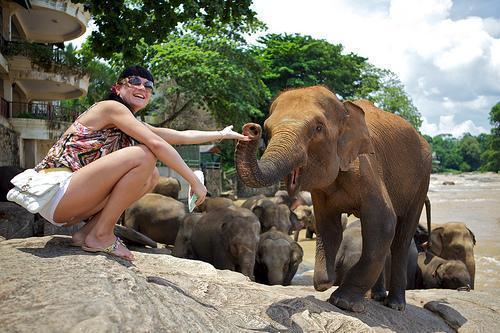How many people are in the picture?
Give a very brief answer. 1. 